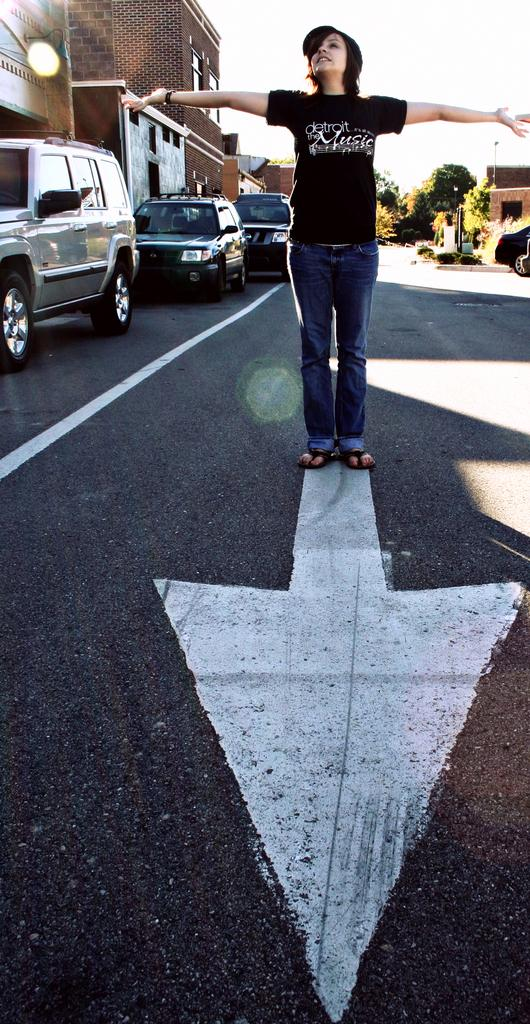What is the main subject of the image? There is a person standing in the image. What can be seen on the road in the image? Cars are visible on the road in the image. What is visible in the background of the image? There are buildings, trees, and the sky visible in the background of the image. What type of pencil is the person holding in the image? There is no pencil present in the image. What type of business is being conducted by the person in the image? The image does not provide any information about the person's business activities. 